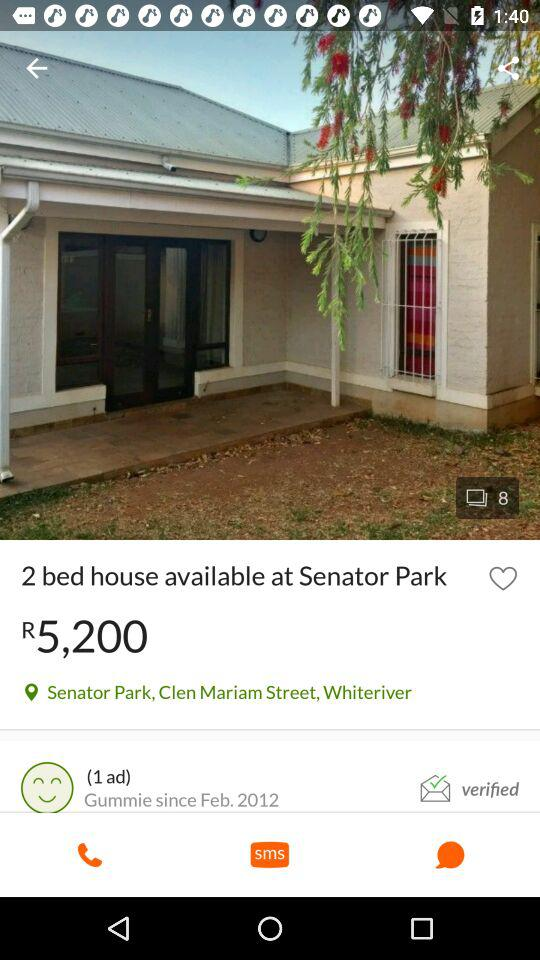How many bedrooms does the house have?
Answer the question using a single word or phrase. 2 